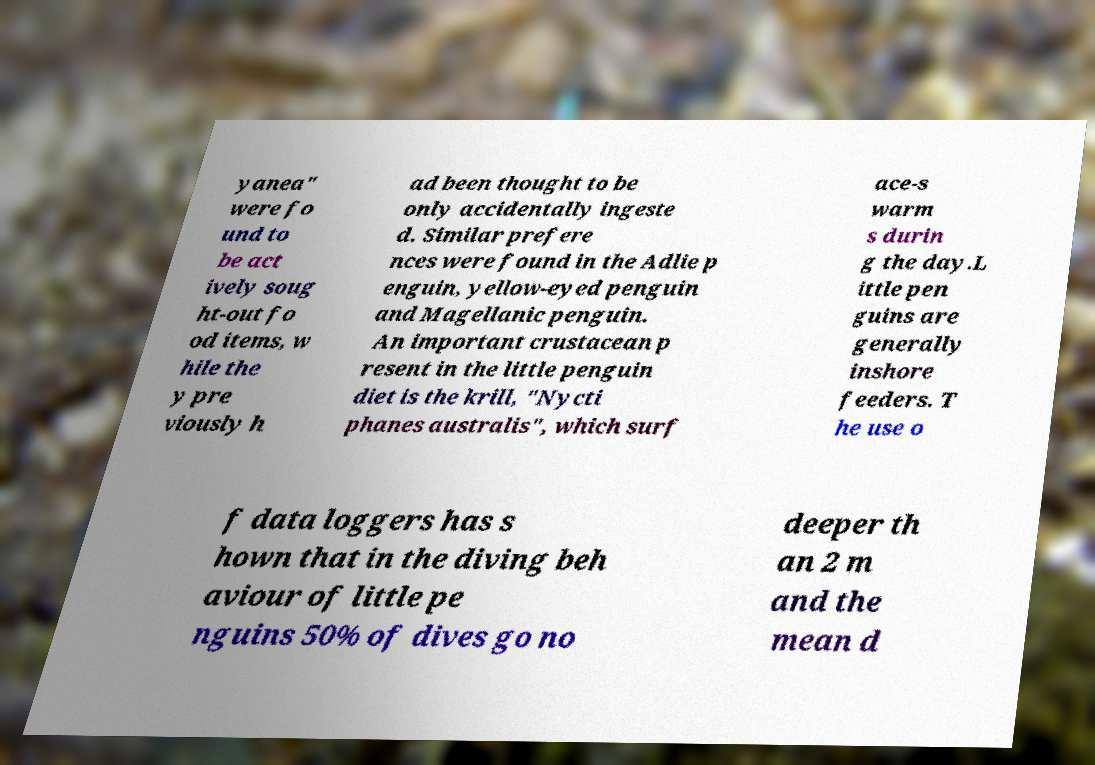I need the written content from this picture converted into text. Can you do that? yanea" were fo und to be act ively soug ht-out fo od items, w hile the y pre viously h ad been thought to be only accidentally ingeste d. Similar prefere nces were found in the Adlie p enguin, yellow-eyed penguin and Magellanic penguin. An important crustacean p resent in the little penguin diet is the krill, "Nycti phanes australis", which surf ace-s warm s durin g the day.L ittle pen guins are generally inshore feeders. T he use o f data loggers has s hown that in the diving beh aviour of little pe nguins 50% of dives go no deeper th an 2 m and the mean d 